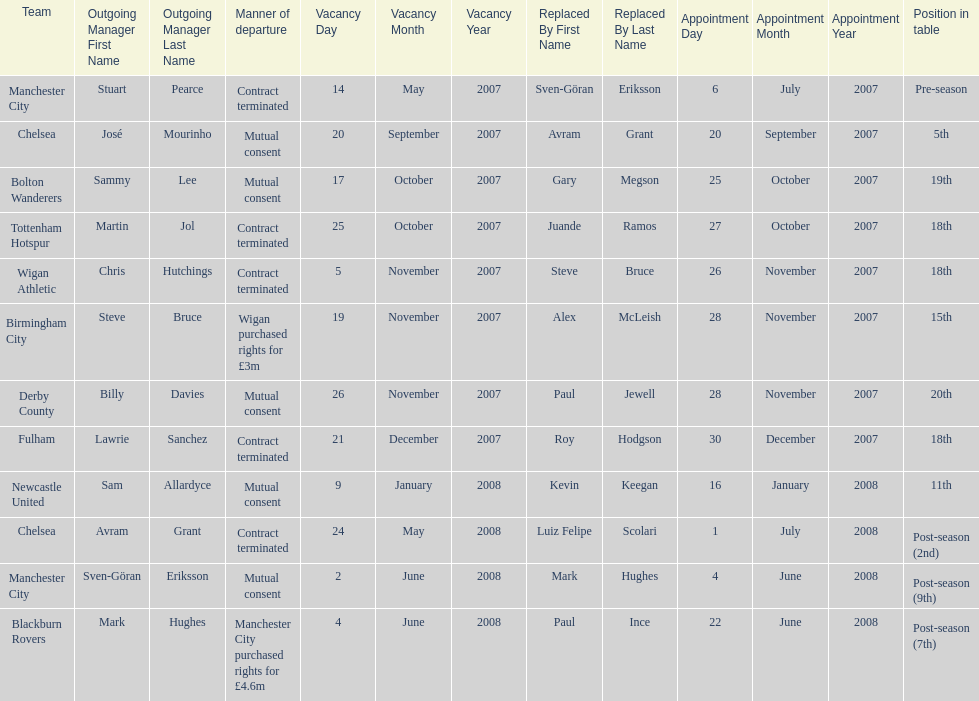Which new manager was purchased for the most money in the 2007-08 premier league season? Mark Hughes. 